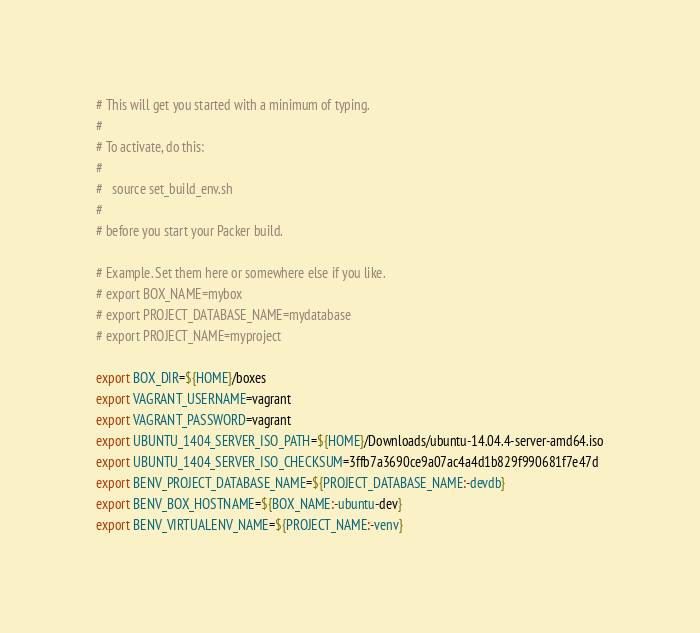<code> <loc_0><loc_0><loc_500><loc_500><_Bash_># This will get you started with a minimum of typing.
#
# To activate, do this:
#
#   source set_build_env.sh
#
# before you start your Packer build.

# Example. Set them here or somewhere else if you like.
# export BOX_NAME=mybox
# export PROJECT_DATABASE_NAME=mydatabase
# export PROJECT_NAME=myproject

export BOX_DIR=${HOME}/boxes
export VAGRANT_USERNAME=vagrant
export VAGRANT_PASSWORD=vagrant
export UBUNTU_1404_SERVER_ISO_PATH=${HOME}/Downloads/ubuntu-14.04.4-server-amd64.iso
export UBUNTU_1404_SERVER_ISO_CHECKSUM=3ffb7a3690ce9a07ac4a4d1b829f990681f7e47d
export BENV_PROJECT_DATABASE_NAME=${PROJECT_DATABASE_NAME:-devdb}
export BENV_BOX_HOSTNAME=${BOX_NAME:-ubuntu-dev}
export BENV_VIRTUALENV_NAME=${PROJECT_NAME:-venv}

</code> 